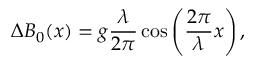<formula> <loc_0><loc_0><loc_500><loc_500>\Delta B _ { 0 } ( x ) = g \frac { \lambda } { 2 \pi } \cos \left ( \frac { 2 \pi } { \lambda } x \right ) ,</formula> 